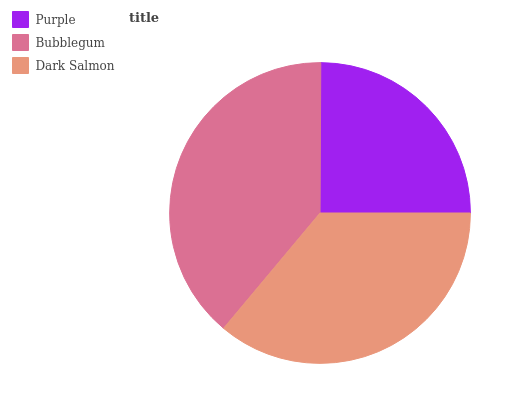Is Purple the minimum?
Answer yes or no. Yes. Is Bubblegum the maximum?
Answer yes or no. Yes. Is Dark Salmon the minimum?
Answer yes or no. No. Is Dark Salmon the maximum?
Answer yes or no. No. Is Bubblegum greater than Dark Salmon?
Answer yes or no. Yes. Is Dark Salmon less than Bubblegum?
Answer yes or no. Yes. Is Dark Salmon greater than Bubblegum?
Answer yes or no. No. Is Bubblegum less than Dark Salmon?
Answer yes or no. No. Is Dark Salmon the high median?
Answer yes or no. Yes. Is Dark Salmon the low median?
Answer yes or no. Yes. Is Bubblegum the high median?
Answer yes or no. No. Is Purple the low median?
Answer yes or no. No. 